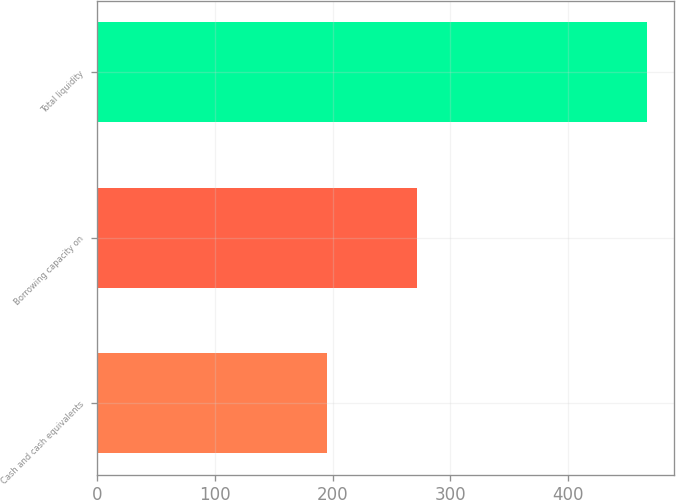<chart> <loc_0><loc_0><loc_500><loc_500><bar_chart><fcel>Cash and cash equivalents<fcel>Borrowing capacity on<fcel>Total liquidity<nl><fcel>195<fcel>272<fcel>467<nl></chart> 